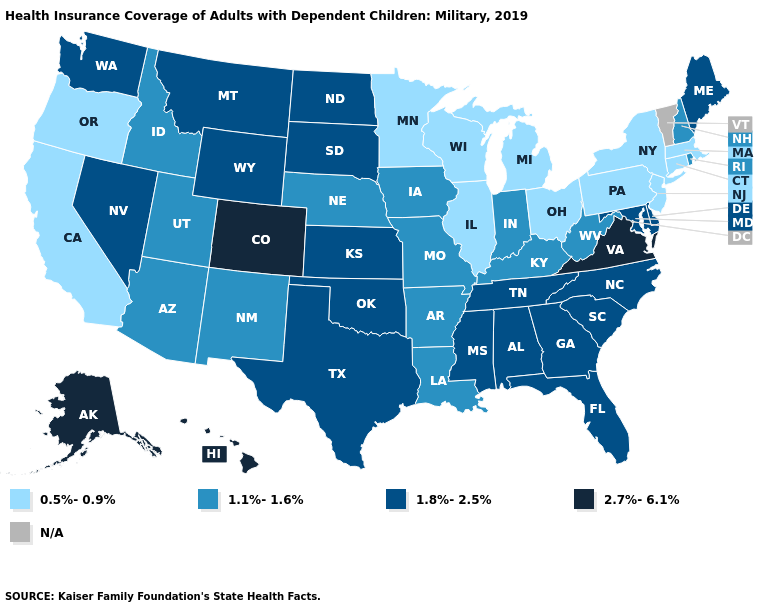Is the legend a continuous bar?
Quick response, please. No. What is the lowest value in states that border Idaho?
Keep it brief. 0.5%-0.9%. Which states hav the highest value in the Northeast?
Quick response, please. Maine. What is the lowest value in the USA?
Write a very short answer. 0.5%-0.9%. Among the states that border Texas , which have the lowest value?
Be succinct. Arkansas, Louisiana, New Mexico. Does Kentucky have the lowest value in the South?
Answer briefly. Yes. What is the lowest value in the West?
Answer briefly. 0.5%-0.9%. What is the value of West Virginia?
Answer briefly. 1.1%-1.6%. What is the value of Virginia?
Quick response, please. 2.7%-6.1%. Among the states that border Delaware , does Maryland have the lowest value?
Short answer required. No. Does New Hampshire have the highest value in the Northeast?
Concise answer only. No. What is the highest value in the USA?
Write a very short answer. 2.7%-6.1%. Which states have the lowest value in the USA?
Be succinct. California, Connecticut, Illinois, Massachusetts, Michigan, Minnesota, New Jersey, New York, Ohio, Oregon, Pennsylvania, Wisconsin. 